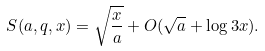Convert formula to latex. <formula><loc_0><loc_0><loc_500><loc_500>S ( a , q , x ) = \sqrt { \frac { x } { a } } + O ( \sqrt { a } + \log { 3 x } ) .</formula> 